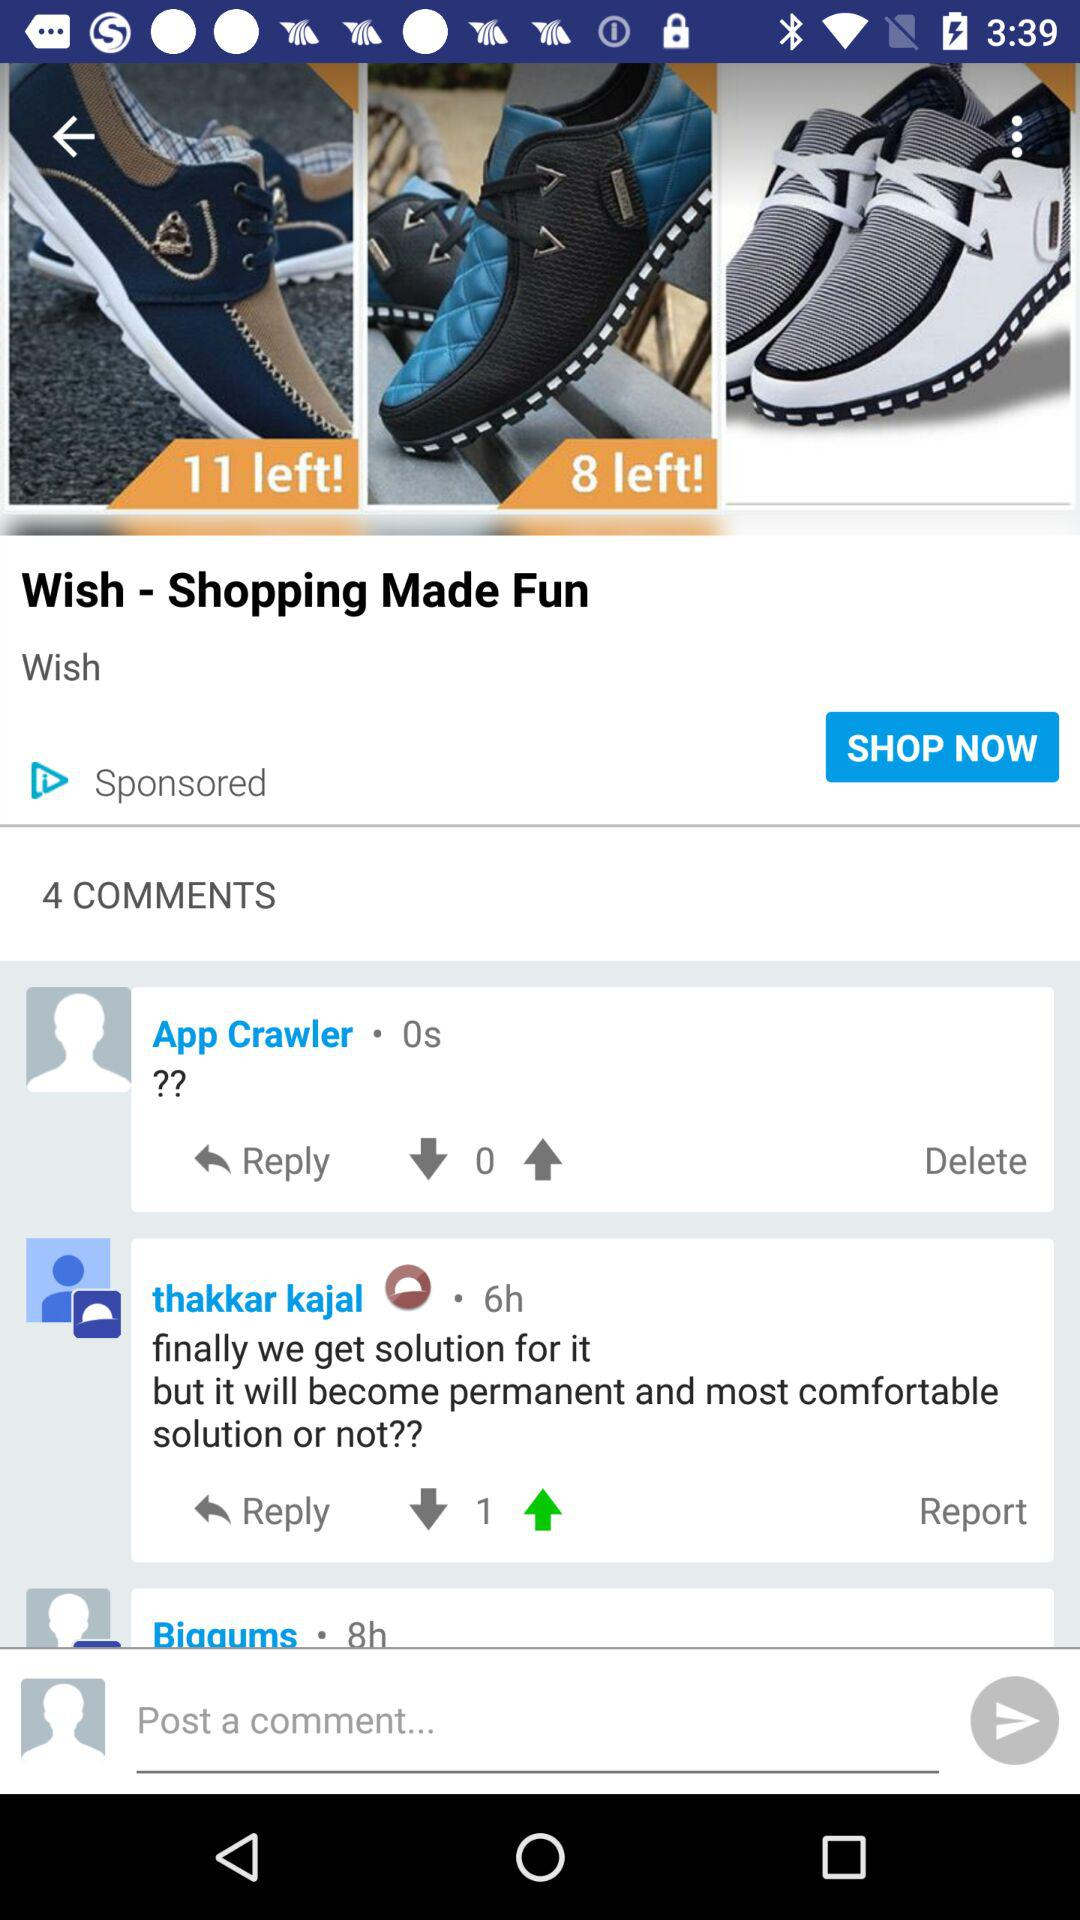Who got a like on their comment?
When the provided information is insufficient, respond with <no answer>. <no answer> 